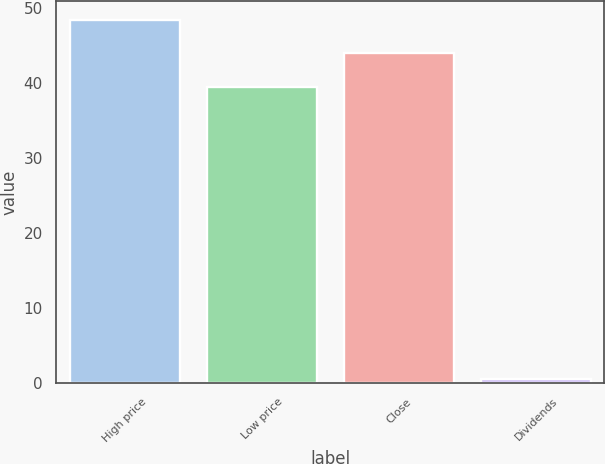Convert chart. <chart><loc_0><loc_0><loc_500><loc_500><bar_chart><fcel>High price<fcel>Low price<fcel>Close<fcel>Dividends<nl><fcel>48.45<fcel>39.51<fcel>43.98<fcel>0.53<nl></chart> 